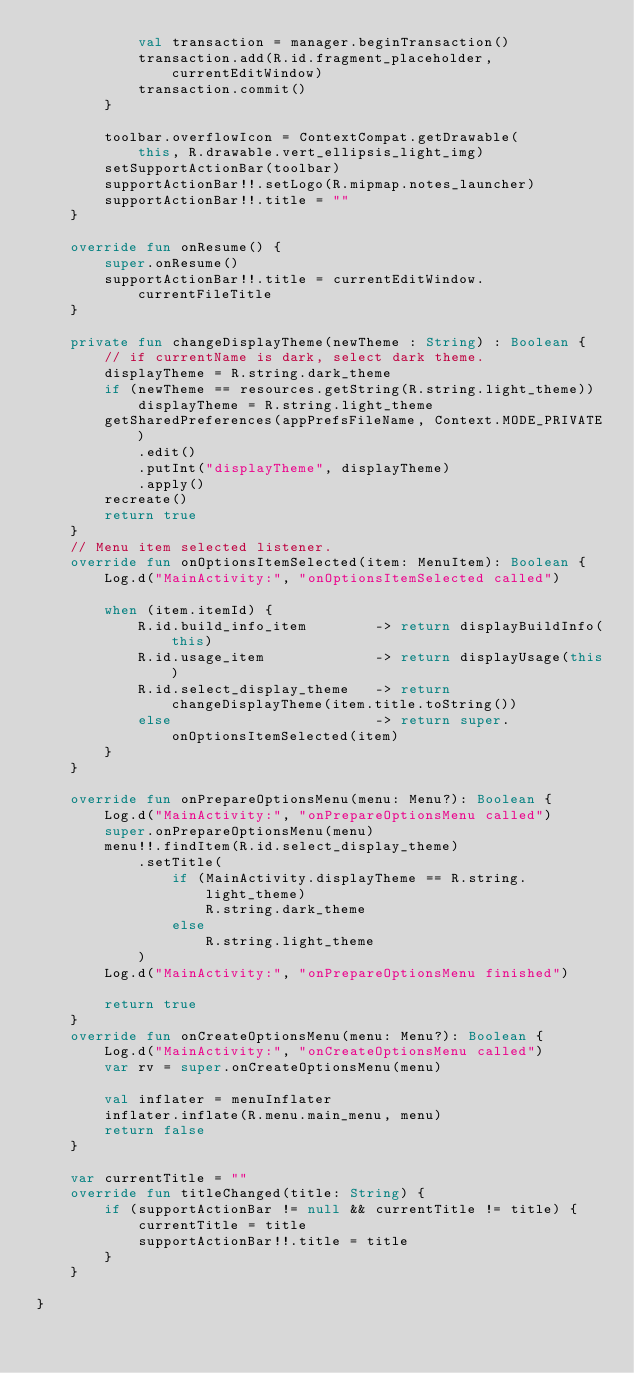<code> <loc_0><loc_0><loc_500><loc_500><_Kotlin_>            val transaction = manager.beginTransaction()
            transaction.add(R.id.fragment_placeholder, currentEditWindow)
            transaction.commit()
        }

        toolbar.overflowIcon = ContextCompat.getDrawable(
            this, R.drawable.vert_ellipsis_light_img)
        setSupportActionBar(toolbar)
        supportActionBar!!.setLogo(R.mipmap.notes_launcher)
        supportActionBar!!.title = ""
    }

    override fun onResume() {
        super.onResume()
        supportActionBar!!.title = currentEditWindow.currentFileTitle
    }

    private fun changeDisplayTheme(newTheme : String) : Boolean {
        // if currentName is dark, select dark theme.
        displayTheme = R.string.dark_theme
        if (newTheme == resources.getString(R.string.light_theme))
            displayTheme = R.string.light_theme
        getSharedPreferences(appPrefsFileName, Context.MODE_PRIVATE)
            .edit()
            .putInt("displayTheme", displayTheme)
            .apply()
        recreate()
        return true
    }
    // Menu item selected listener.
    override fun onOptionsItemSelected(item: MenuItem): Boolean {
        Log.d("MainActivity:", "onOptionsItemSelected called")

        when (item.itemId) {
            R.id.build_info_item        -> return displayBuildInfo(this)
            R.id.usage_item             -> return displayUsage(this)
            R.id.select_display_theme   -> return changeDisplayTheme(item.title.toString())
            else                        -> return super.onOptionsItemSelected(item)
        }
    }

    override fun onPrepareOptionsMenu(menu: Menu?): Boolean {
        Log.d("MainActivity:", "onPrepareOptionsMenu called")
        super.onPrepareOptionsMenu(menu)
        menu!!.findItem(R.id.select_display_theme)
            .setTitle(
                if (MainActivity.displayTheme == R.string.light_theme)
                    R.string.dark_theme
                else
                    R.string.light_theme
            )
        Log.d("MainActivity:", "onPrepareOptionsMenu finished")

        return true
    }
    override fun onCreateOptionsMenu(menu: Menu?): Boolean {
        Log.d("MainActivity:", "onCreateOptionsMenu called")
        var rv = super.onCreateOptionsMenu(menu)

        val inflater = menuInflater
        inflater.inflate(R.menu.main_menu, menu)
        return false
    }

    var currentTitle = ""
    override fun titleChanged(title: String) {
        if (supportActionBar != null && currentTitle != title) {
            currentTitle = title
            supportActionBar!!.title = title
        }
    }

}


</code> 